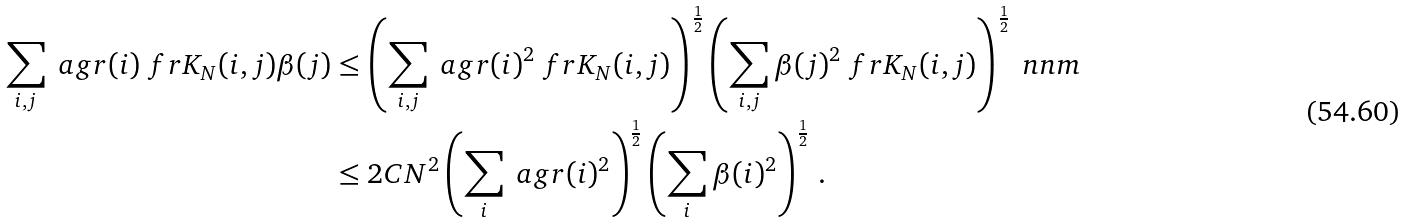<formula> <loc_0><loc_0><loc_500><loc_500>\sum _ { i , j } \ a g r ( i ) \ f r K _ { N } ( i , j ) \beta ( j ) & \leq \left ( \sum _ { i , j } \ a g r ( i ) ^ { 2 } \ f r K _ { N } ( i , j ) \right ) ^ { \frac { 1 } { 2 } } \left ( \sum _ { i , j } \beta ( j ) ^ { 2 } \ f r K _ { N } ( i , j ) \right ) ^ { \frac { 1 } { 2 } } \ n n m \\ & \leq 2 C N ^ { 2 } \left ( \sum _ { i } \ a g r ( i ) ^ { 2 } \right ) ^ { \frac { 1 } { 2 } } \left ( \sum _ { i } \beta ( i ) ^ { 2 } \right ) ^ { \frac { 1 } { 2 } } \, .</formula> 